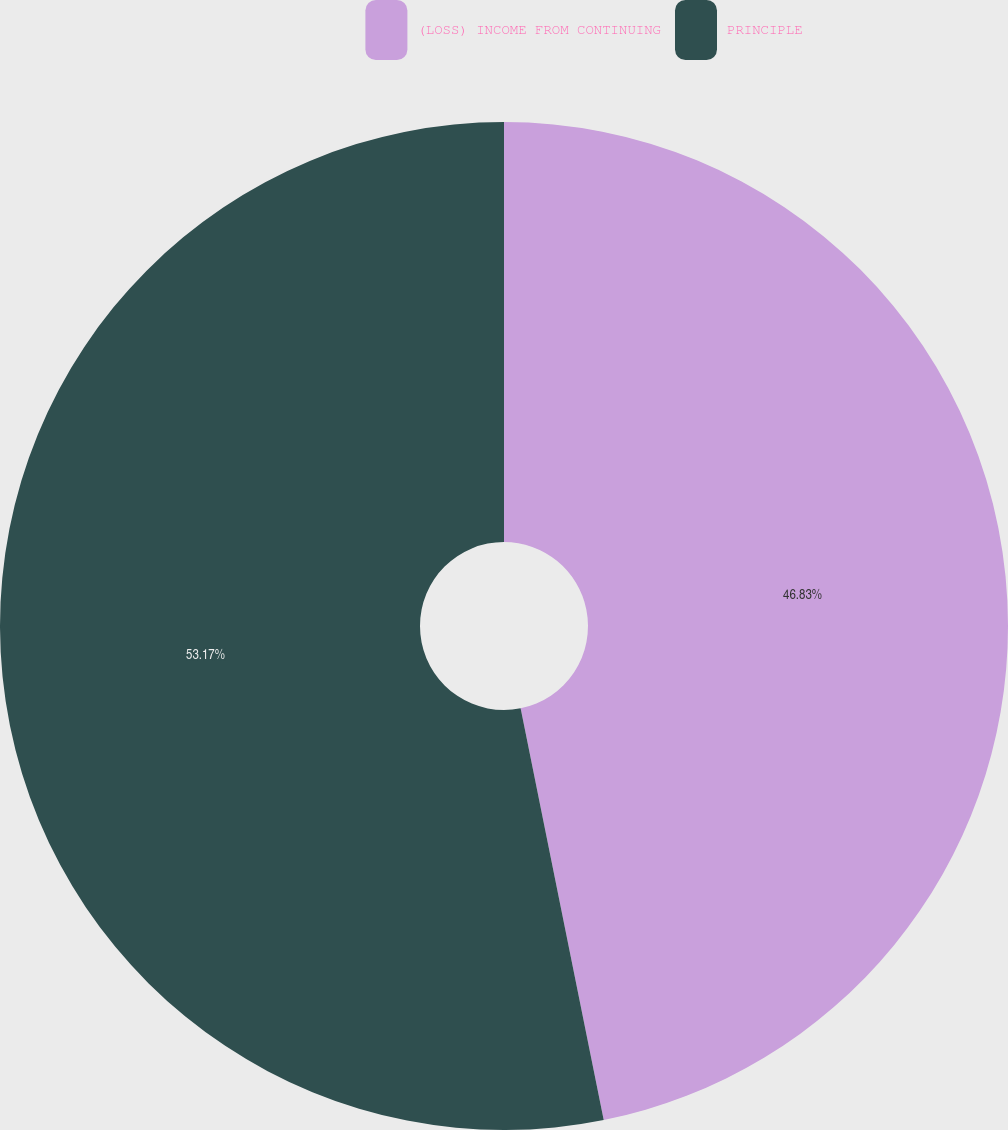Convert chart to OTSL. <chart><loc_0><loc_0><loc_500><loc_500><pie_chart><fcel>(LOSS) INCOME FROM CONTINUING<fcel>PRINCIPLE<nl><fcel>46.83%<fcel>53.17%<nl></chart> 